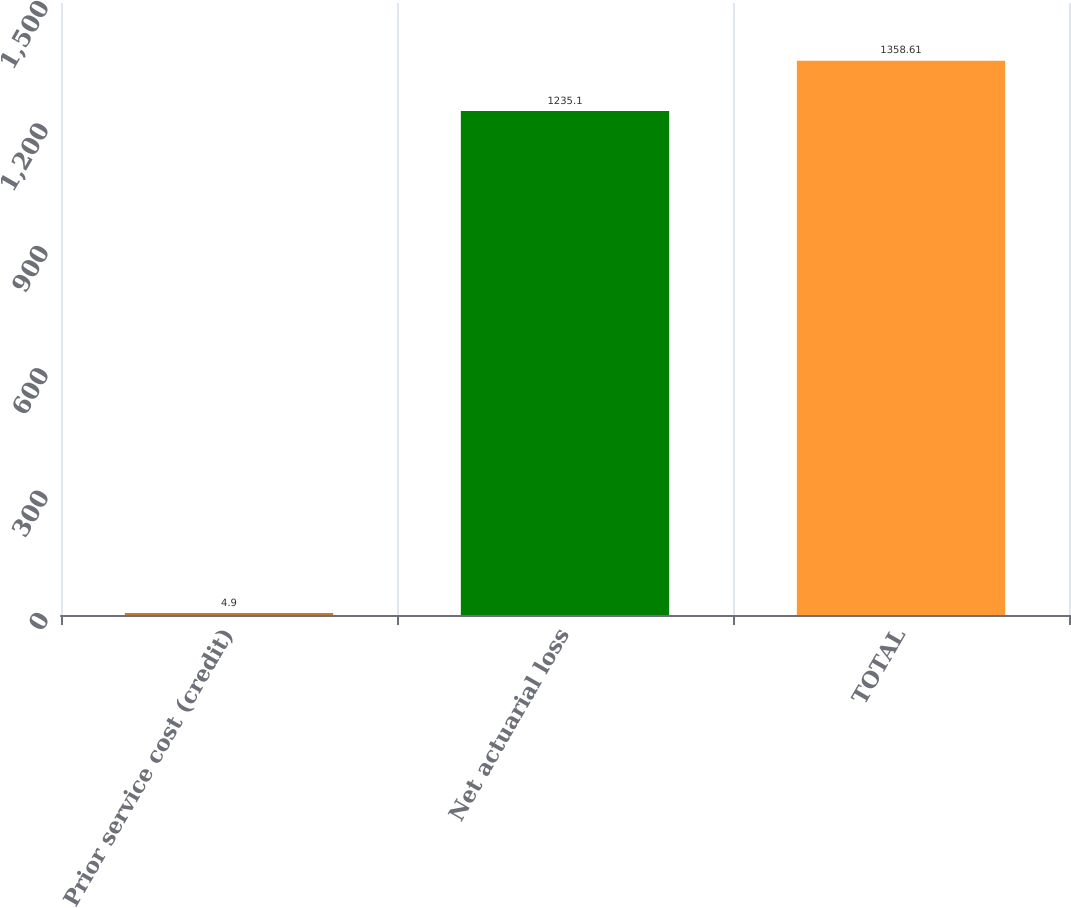Convert chart to OTSL. <chart><loc_0><loc_0><loc_500><loc_500><bar_chart><fcel>Prior service cost (credit)<fcel>Net actuarial loss<fcel>TOTAL<nl><fcel>4.9<fcel>1235.1<fcel>1358.61<nl></chart> 